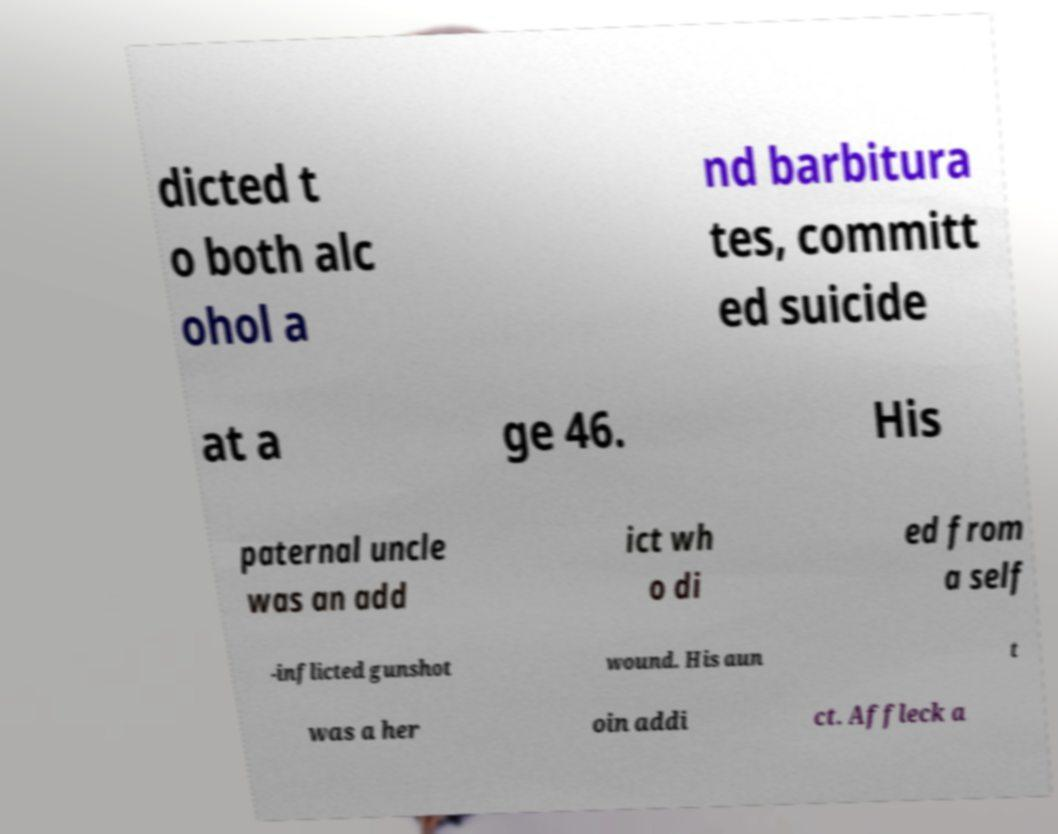There's text embedded in this image that I need extracted. Can you transcribe it verbatim? dicted t o both alc ohol a nd barbitura tes, committ ed suicide at a ge 46. His paternal uncle was an add ict wh o di ed from a self -inflicted gunshot wound. His aun t was a her oin addi ct. Affleck a 